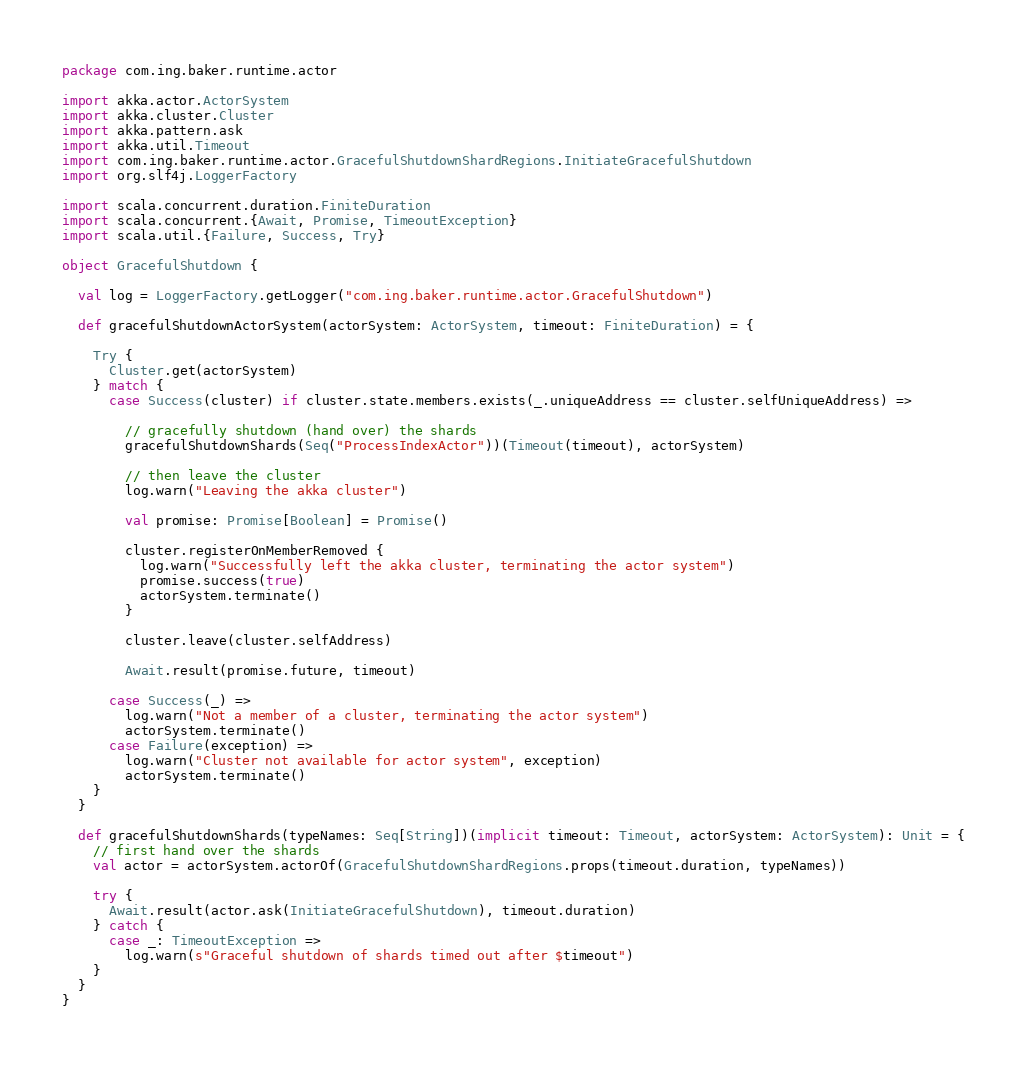<code> <loc_0><loc_0><loc_500><loc_500><_Scala_>package com.ing.baker.runtime.actor

import akka.actor.ActorSystem
import akka.cluster.Cluster
import akka.pattern.ask
import akka.util.Timeout
import com.ing.baker.runtime.actor.GracefulShutdownShardRegions.InitiateGracefulShutdown
import org.slf4j.LoggerFactory

import scala.concurrent.duration.FiniteDuration
import scala.concurrent.{Await, Promise, TimeoutException}
import scala.util.{Failure, Success, Try}

object GracefulShutdown {

  val log = LoggerFactory.getLogger("com.ing.baker.runtime.actor.GracefulShutdown")

  def gracefulShutdownActorSystem(actorSystem: ActorSystem, timeout: FiniteDuration) = {

    Try {
      Cluster.get(actorSystem)
    } match {
      case Success(cluster) if cluster.state.members.exists(_.uniqueAddress == cluster.selfUniqueAddress) =>

        // gracefully shutdown (hand over) the shards
        gracefulShutdownShards(Seq("ProcessIndexActor"))(Timeout(timeout), actorSystem)

        // then leave the cluster
        log.warn("Leaving the akka cluster")

        val promise: Promise[Boolean] = Promise()

        cluster.registerOnMemberRemoved {
          log.warn("Successfully left the akka cluster, terminating the actor system")
          promise.success(true)
          actorSystem.terminate()
        }

        cluster.leave(cluster.selfAddress)

        Await.result(promise.future, timeout)

      case Success(_) =>
        log.warn("Not a member of a cluster, terminating the actor system")
        actorSystem.terminate()
      case Failure(exception) =>
        log.warn("Cluster not available for actor system", exception)
        actorSystem.terminate()
    }
  }

  def gracefulShutdownShards(typeNames: Seq[String])(implicit timeout: Timeout, actorSystem: ActorSystem): Unit = {
    // first hand over the shards
    val actor = actorSystem.actorOf(GracefulShutdownShardRegions.props(timeout.duration, typeNames))

    try {
      Await.result(actor.ask(InitiateGracefulShutdown), timeout.duration)
    } catch {
      case _: TimeoutException =>
        log.warn(s"Graceful shutdown of shards timed out after $timeout")
    }
  }
}
</code> 